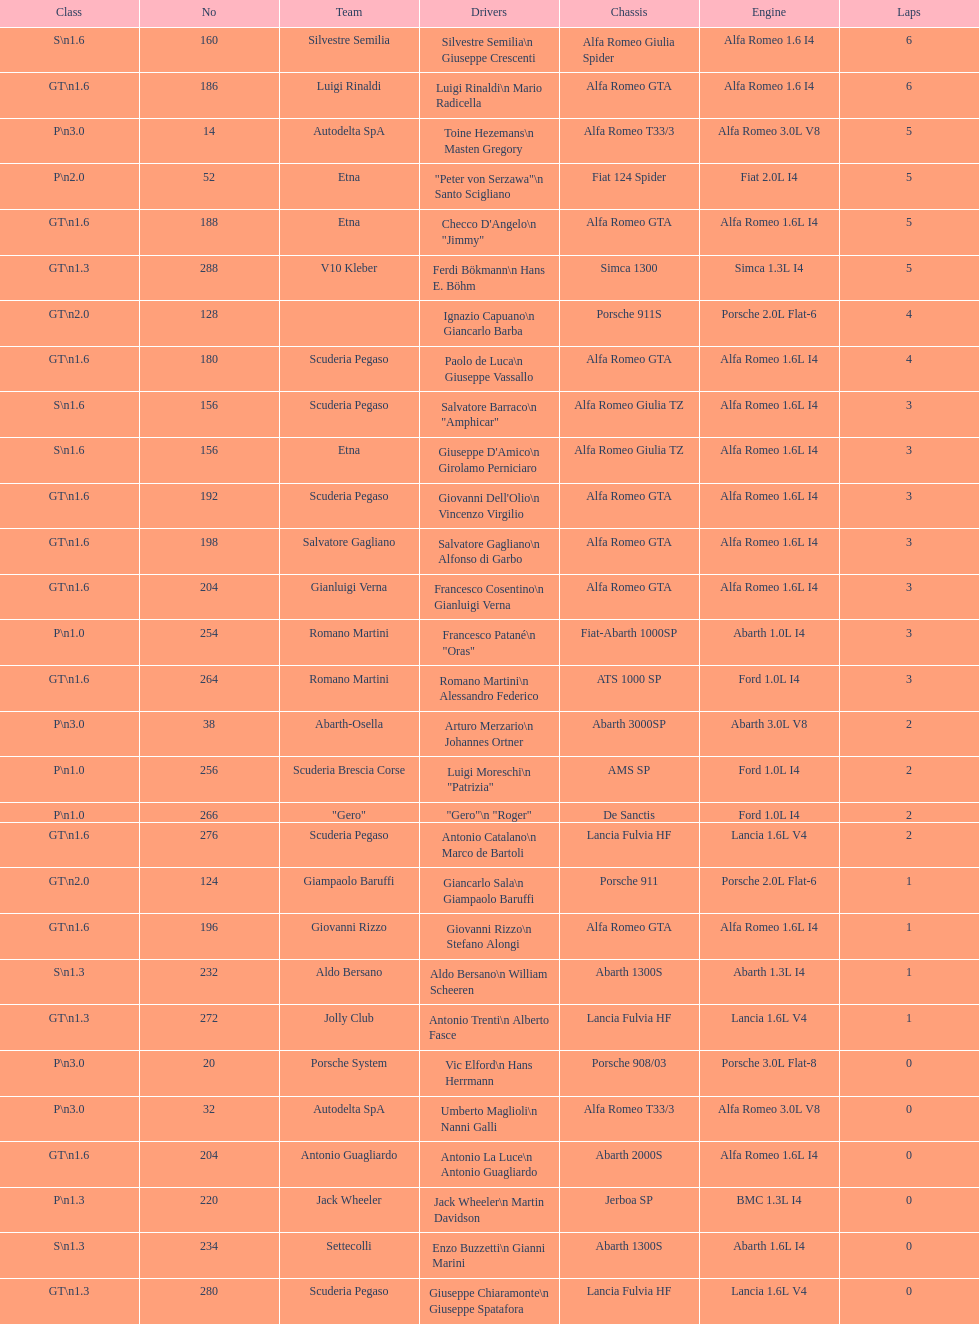What is the count of drivers hailing from italy? 48. 